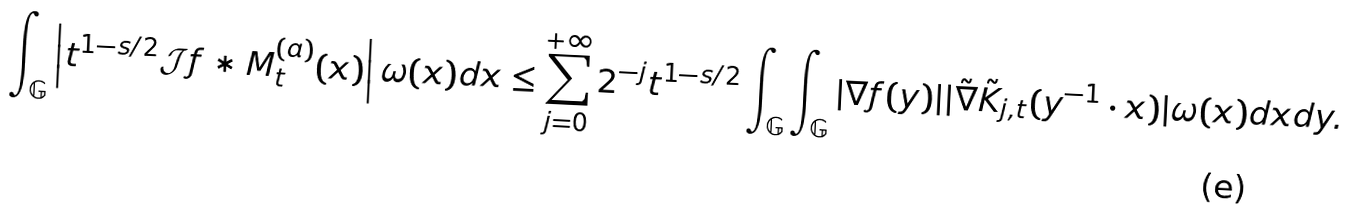<formula> <loc_0><loc_0><loc_500><loc_500>\int _ { \mathbb { G } } \left | t ^ { 1 - s / 2 } \mathcal { J } f \ast M ^ { ( a ) } _ { t } ( x ) \right | \omega ( x ) d x \leq \sum ^ { + \infty } _ { j = 0 } 2 ^ { - j } t ^ { 1 - s / 2 } \int _ { \mathbb { G } } \int _ { \mathbb { G } } | \nabla f ( y ) | | \tilde { \nabla } \tilde { K } _ { j , t } ( y ^ { - 1 } \cdot x ) | \omega ( x ) d x d y .</formula> 